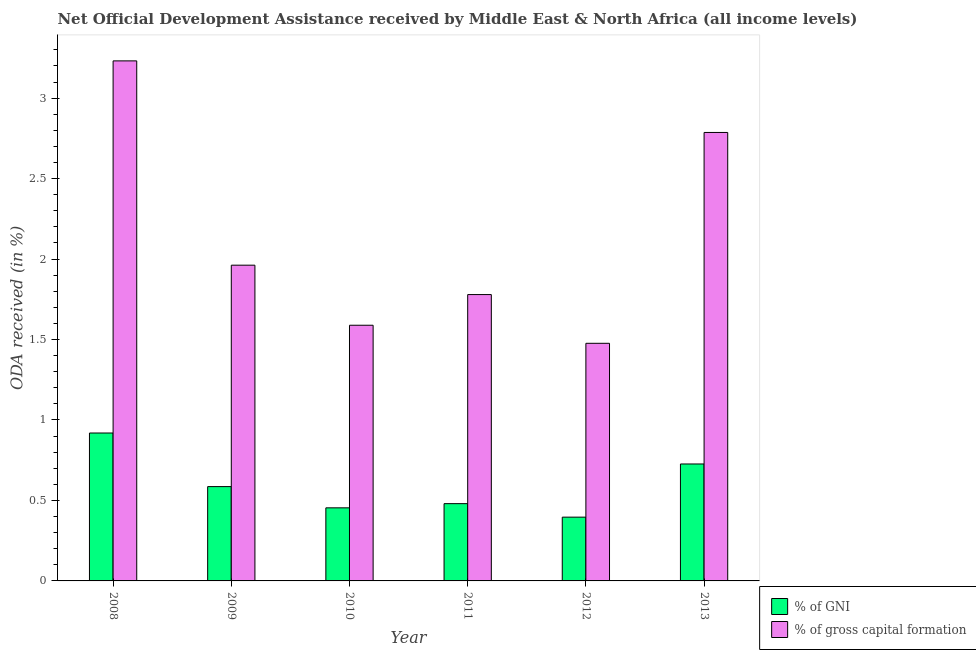Are the number of bars per tick equal to the number of legend labels?
Your answer should be very brief. Yes. Are the number of bars on each tick of the X-axis equal?
Provide a short and direct response. Yes. How many bars are there on the 4th tick from the right?
Your answer should be very brief. 2. What is the oda received as percentage of gross capital formation in 2012?
Offer a terse response. 1.48. Across all years, what is the maximum oda received as percentage of gni?
Provide a succinct answer. 0.92. Across all years, what is the minimum oda received as percentage of gni?
Make the answer very short. 0.4. In which year was the oda received as percentage of gni maximum?
Offer a very short reply. 2008. In which year was the oda received as percentage of gni minimum?
Keep it short and to the point. 2012. What is the total oda received as percentage of gross capital formation in the graph?
Give a very brief answer. 12.83. What is the difference between the oda received as percentage of gni in 2010 and that in 2011?
Make the answer very short. -0.03. What is the difference between the oda received as percentage of gross capital formation in 2008 and the oda received as percentage of gni in 2010?
Make the answer very short. 1.64. What is the average oda received as percentage of gni per year?
Give a very brief answer. 0.59. What is the ratio of the oda received as percentage of gross capital formation in 2008 to that in 2012?
Your answer should be compact. 2.19. Is the difference between the oda received as percentage of gni in 2009 and 2010 greater than the difference between the oda received as percentage of gross capital formation in 2009 and 2010?
Give a very brief answer. No. What is the difference between the highest and the second highest oda received as percentage of gni?
Offer a terse response. 0.19. What is the difference between the highest and the lowest oda received as percentage of gni?
Provide a succinct answer. 0.52. What does the 2nd bar from the left in 2013 represents?
Offer a terse response. % of gross capital formation. What does the 1st bar from the right in 2008 represents?
Ensure brevity in your answer.  % of gross capital formation. Are all the bars in the graph horizontal?
Offer a terse response. No. What is the difference between two consecutive major ticks on the Y-axis?
Your response must be concise. 0.5. Are the values on the major ticks of Y-axis written in scientific E-notation?
Offer a very short reply. No. Does the graph contain any zero values?
Ensure brevity in your answer.  No. How many legend labels are there?
Ensure brevity in your answer.  2. What is the title of the graph?
Offer a very short reply. Net Official Development Assistance received by Middle East & North Africa (all income levels). Does "Short-term debt" appear as one of the legend labels in the graph?
Keep it short and to the point. No. What is the label or title of the Y-axis?
Give a very brief answer. ODA received (in %). What is the ODA received (in %) of % of GNI in 2008?
Offer a very short reply. 0.92. What is the ODA received (in %) of % of gross capital formation in 2008?
Your answer should be very brief. 3.23. What is the ODA received (in %) in % of GNI in 2009?
Make the answer very short. 0.59. What is the ODA received (in %) in % of gross capital formation in 2009?
Offer a terse response. 1.96. What is the ODA received (in %) in % of GNI in 2010?
Offer a terse response. 0.45. What is the ODA received (in %) in % of gross capital formation in 2010?
Your answer should be compact. 1.59. What is the ODA received (in %) of % of GNI in 2011?
Offer a terse response. 0.48. What is the ODA received (in %) in % of gross capital formation in 2011?
Offer a terse response. 1.78. What is the ODA received (in %) of % of GNI in 2012?
Keep it short and to the point. 0.4. What is the ODA received (in %) in % of gross capital formation in 2012?
Ensure brevity in your answer.  1.48. What is the ODA received (in %) in % of GNI in 2013?
Ensure brevity in your answer.  0.73. What is the ODA received (in %) of % of gross capital formation in 2013?
Offer a terse response. 2.79. Across all years, what is the maximum ODA received (in %) in % of GNI?
Provide a short and direct response. 0.92. Across all years, what is the maximum ODA received (in %) in % of gross capital formation?
Provide a short and direct response. 3.23. Across all years, what is the minimum ODA received (in %) in % of GNI?
Offer a very short reply. 0.4. Across all years, what is the minimum ODA received (in %) in % of gross capital formation?
Make the answer very short. 1.48. What is the total ODA received (in %) in % of GNI in the graph?
Your answer should be very brief. 3.56. What is the total ODA received (in %) in % of gross capital formation in the graph?
Ensure brevity in your answer.  12.83. What is the difference between the ODA received (in %) of % of GNI in 2008 and that in 2009?
Ensure brevity in your answer.  0.33. What is the difference between the ODA received (in %) of % of gross capital formation in 2008 and that in 2009?
Give a very brief answer. 1.27. What is the difference between the ODA received (in %) of % of GNI in 2008 and that in 2010?
Provide a succinct answer. 0.47. What is the difference between the ODA received (in %) of % of gross capital formation in 2008 and that in 2010?
Make the answer very short. 1.64. What is the difference between the ODA received (in %) of % of GNI in 2008 and that in 2011?
Provide a short and direct response. 0.44. What is the difference between the ODA received (in %) of % of gross capital formation in 2008 and that in 2011?
Offer a terse response. 1.45. What is the difference between the ODA received (in %) of % of GNI in 2008 and that in 2012?
Offer a terse response. 0.52. What is the difference between the ODA received (in %) in % of gross capital formation in 2008 and that in 2012?
Offer a terse response. 1.76. What is the difference between the ODA received (in %) in % of GNI in 2008 and that in 2013?
Your answer should be compact. 0.19. What is the difference between the ODA received (in %) in % of gross capital formation in 2008 and that in 2013?
Provide a short and direct response. 0.44. What is the difference between the ODA received (in %) in % of GNI in 2009 and that in 2010?
Offer a very short reply. 0.13. What is the difference between the ODA received (in %) in % of gross capital formation in 2009 and that in 2010?
Ensure brevity in your answer.  0.37. What is the difference between the ODA received (in %) in % of GNI in 2009 and that in 2011?
Offer a very short reply. 0.11. What is the difference between the ODA received (in %) in % of gross capital formation in 2009 and that in 2011?
Your response must be concise. 0.18. What is the difference between the ODA received (in %) of % of GNI in 2009 and that in 2012?
Your answer should be very brief. 0.19. What is the difference between the ODA received (in %) of % of gross capital formation in 2009 and that in 2012?
Provide a succinct answer. 0.49. What is the difference between the ODA received (in %) in % of GNI in 2009 and that in 2013?
Your answer should be compact. -0.14. What is the difference between the ODA received (in %) in % of gross capital formation in 2009 and that in 2013?
Make the answer very short. -0.82. What is the difference between the ODA received (in %) in % of GNI in 2010 and that in 2011?
Keep it short and to the point. -0.03. What is the difference between the ODA received (in %) in % of gross capital formation in 2010 and that in 2011?
Your answer should be compact. -0.19. What is the difference between the ODA received (in %) of % of GNI in 2010 and that in 2012?
Make the answer very short. 0.06. What is the difference between the ODA received (in %) of % of gross capital formation in 2010 and that in 2012?
Your answer should be compact. 0.11. What is the difference between the ODA received (in %) in % of GNI in 2010 and that in 2013?
Offer a terse response. -0.27. What is the difference between the ODA received (in %) of % of gross capital formation in 2010 and that in 2013?
Make the answer very short. -1.2. What is the difference between the ODA received (in %) in % of GNI in 2011 and that in 2012?
Keep it short and to the point. 0.08. What is the difference between the ODA received (in %) of % of gross capital formation in 2011 and that in 2012?
Your answer should be very brief. 0.3. What is the difference between the ODA received (in %) in % of GNI in 2011 and that in 2013?
Your response must be concise. -0.25. What is the difference between the ODA received (in %) of % of gross capital formation in 2011 and that in 2013?
Provide a succinct answer. -1.01. What is the difference between the ODA received (in %) of % of GNI in 2012 and that in 2013?
Keep it short and to the point. -0.33. What is the difference between the ODA received (in %) in % of gross capital formation in 2012 and that in 2013?
Offer a terse response. -1.31. What is the difference between the ODA received (in %) of % of GNI in 2008 and the ODA received (in %) of % of gross capital formation in 2009?
Keep it short and to the point. -1.04. What is the difference between the ODA received (in %) in % of GNI in 2008 and the ODA received (in %) in % of gross capital formation in 2010?
Provide a short and direct response. -0.67. What is the difference between the ODA received (in %) in % of GNI in 2008 and the ODA received (in %) in % of gross capital formation in 2011?
Offer a terse response. -0.86. What is the difference between the ODA received (in %) in % of GNI in 2008 and the ODA received (in %) in % of gross capital formation in 2012?
Ensure brevity in your answer.  -0.56. What is the difference between the ODA received (in %) of % of GNI in 2008 and the ODA received (in %) of % of gross capital formation in 2013?
Offer a terse response. -1.87. What is the difference between the ODA received (in %) in % of GNI in 2009 and the ODA received (in %) in % of gross capital formation in 2010?
Provide a short and direct response. -1. What is the difference between the ODA received (in %) in % of GNI in 2009 and the ODA received (in %) in % of gross capital formation in 2011?
Offer a very short reply. -1.19. What is the difference between the ODA received (in %) in % of GNI in 2009 and the ODA received (in %) in % of gross capital formation in 2012?
Keep it short and to the point. -0.89. What is the difference between the ODA received (in %) in % of GNI in 2009 and the ODA received (in %) in % of gross capital formation in 2013?
Provide a succinct answer. -2.2. What is the difference between the ODA received (in %) in % of GNI in 2010 and the ODA received (in %) in % of gross capital formation in 2011?
Give a very brief answer. -1.33. What is the difference between the ODA received (in %) of % of GNI in 2010 and the ODA received (in %) of % of gross capital formation in 2012?
Your response must be concise. -1.02. What is the difference between the ODA received (in %) in % of GNI in 2010 and the ODA received (in %) in % of gross capital formation in 2013?
Offer a very short reply. -2.33. What is the difference between the ODA received (in %) of % of GNI in 2011 and the ODA received (in %) of % of gross capital formation in 2012?
Give a very brief answer. -1. What is the difference between the ODA received (in %) of % of GNI in 2011 and the ODA received (in %) of % of gross capital formation in 2013?
Keep it short and to the point. -2.31. What is the difference between the ODA received (in %) in % of GNI in 2012 and the ODA received (in %) in % of gross capital formation in 2013?
Provide a short and direct response. -2.39. What is the average ODA received (in %) of % of GNI per year?
Your answer should be compact. 0.59. What is the average ODA received (in %) of % of gross capital formation per year?
Keep it short and to the point. 2.14. In the year 2008, what is the difference between the ODA received (in %) in % of GNI and ODA received (in %) in % of gross capital formation?
Offer a terse response. -2.31. In the year 2009, what is the difference between the ODA received (in %) of % of GNI and ODA received (in %) of % of gross capital formation?
Make the answer very short. -1.38. In the year 2010, what is the difference between the ODA received (in %) in % of GNI and ODA received (in %) in % of gross capital formation?
Your answer should be very brief. -1.13. In the year 2011, what is the difference between the ODA received (in %) of % of GNI and ODA received (in %) of % of gross capital formation?
Offer a terse response. -1.3. In the year 2012, what is the difference between the ODA received (in %) in % of GNI and ODA received (in %) in % of gross capital formation?
Your answer should be compact. -1.08. In the year 2013, what is the difference between the ODA received (in %) in % of GNI and ODA received (in %) in % of gross capital formation?
Your answer should be very brief. -2.06. What is the ratio of the ODA received (in %) of % of GNI in 2008 to that in 2009?
Keep it short and to the point. 1.57. What is the ratio of the ODA received (in %) in % of gross capital formation in 2008 to that in 2009?
Your answer should be compact. 1.65. What is the ratio of the ODA received (in %) of % of GNI in 2008 to that in 2010?
Make the answer very short. 2.02. What is the ratio of the ODA received (in %) of % of gross capital formation in 2008 to that in 2010?
Provide a succinct answer. 2.03. What is the ratio of the ODA received (in %) in % of GNI in 2008 to that in 2011?
Provide a succinct answer. 1.91. What is the ratio of the ODA received (in %) in % of gross capital formation in 2008 to that in 2011?
Ensure brevity in your answer.  1.82. What is the ratio of the ODA received (in %) of % of GNI in 2008 to that in 2012?
Your answer should be very brief. 2.32. What is the ratio of the ODA received (in %) in % of gross capital formation in 2008 to that in 2012?
Provide a succinct answer. 2.19. What is the ratio of the ODA received (in %) of % of GNI in 2008 to that in 2013?
Your answer should be compact. 1.26. What is the ratio of the ODA received (in %) in % of gross capital formation in 2008 to that in 2013?
Keep it short and to the point. 1.16. What is the ratio of the ODA received (in %) of % of GNI in 2009 to that in 2010?
Offer a terse response. 1.29. What is the ratio of the ODA received (in %) in % of gross capital formation in 2009 to that in 2010?
Make the answer very short. 1.23. What is the ratio of the ODA received (in %) of % of GNI in 2009 to that in 2011?
Make the answer very short. 1.22. What is the ratio of the ODA received (in %) of % of gross capital formation in 2009 to that in 2011?
Offer a very short reply. 1.1. What is the ratio of the ODA received (in %) of % of GNI in 2009 to that in 2012?
Provide a succinct answer. 1.48. What is the ratio of the ODA received (in %) in % of gross capital formation in 2009 to that in 2012?
Provide a succinct answer. 1.33. What is the ratio of the ODA received (in %) in % of GNI in 2009 to that in 2013?
Make the answer very short. 0.81. What is the ratio of the ODA received (in %) of % of gross capital formation in 2009 to that in 2013?
Ensure brevity in your answer.  0.7. What is the ratio of the ODA received (in %) of % of GNI in 2010 to that in 2011?
Make the answer very short. 0.95. What is the ratio of the ODA received (in %) in % of gross capital formation in 2010 to that in 2011?
Ensure brevity in your answer.  0.89. What is the ratio of the ODA received (in %) in % of GNI in 2010 to that in 2012?
Give a very brief answer. 1.15. What is the ratio of the ODA received (in %) in % of gross capital formation in 2010 to that in 2012?
Keep it short and to the point. 1.08. What is the ratio of the ODA received (in %) in % of GNI in 2010 to that in 2013?
Your answer should be very brief. 0.62. What is the ratio of the ODA received (in %) in % of gross capital formation in 2010 to that in 2013?
Give a very brief answer. 0.57. What is the ratio of the ODA received (in %) in % of GNI in 2011 to that in 2012?
Ensure brevity in your answer.  1.21. What is the ratio of the ODA received (in %) in % of gross capital formation in 2011 to that in 2012?
Give a very brief answer. 1.21. What is the ratio of the ODA received (in %) of % of GNI in 2011 to that in 2013?
Offer a terse response. 0.66. What is the ratio of the ODA received (in %) of % of gross capital formation in 2011 to that in 2013?
Make the answer very short. 0.64. What is the ratio of the ODA received (in %) of % of GNI in 2012 to that in 2013?
Provide a succinct answer. 0.55. What is the ratio of the ODA received (in %) of % of gross capital formation in 2012 to that in 2013?
Ensure brevity in your answer.  0.53. What is the difference between the highest and the second highest ODA received (in %) in % of GNI?
Make the answer very short. 0.19. What is the difference between the highest and the second highest ODA received (in %) of % of gross capital formation?
Your response must be concise. 0.44. What is the difference between the highest and the lowest ODA received (in %) in % of GNI?
Make the answer very short. 0.52. What is the difference between the highest and the lowest ODA received (in %) of % of gross capital formation?
Provide a short and direct response. 1.76. 